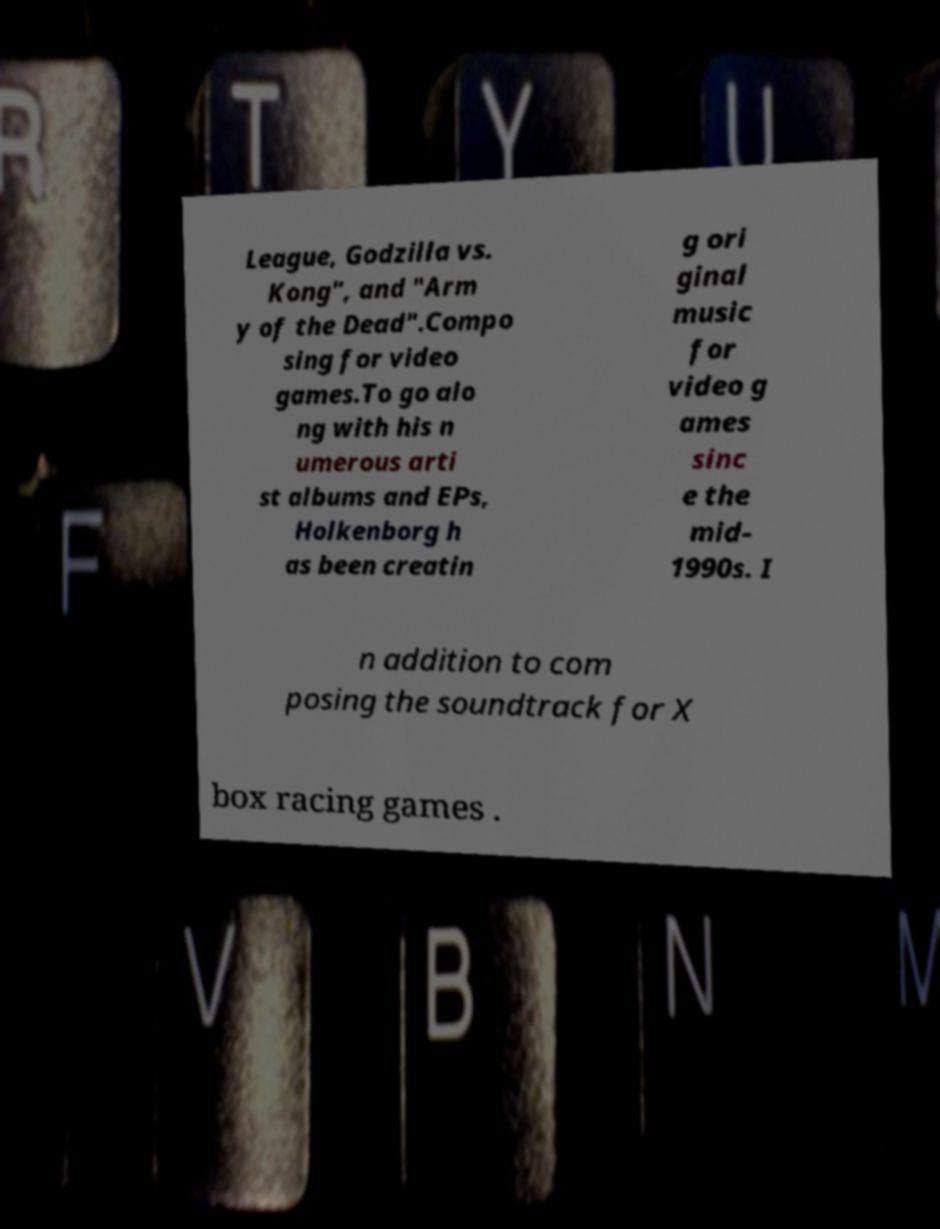Could you extract and type out the text from this image? League, Godzilla vs. Kong", and "Arm y of the Dead".Compo sing for video games.To go alo ng with his n umerous arti st albums and EPs, Holkenborg h as been creatin g ori ginal music for video g ames sinc e the mid- 1990s. I n addition to com posing the soundtrack for X box racing games . 